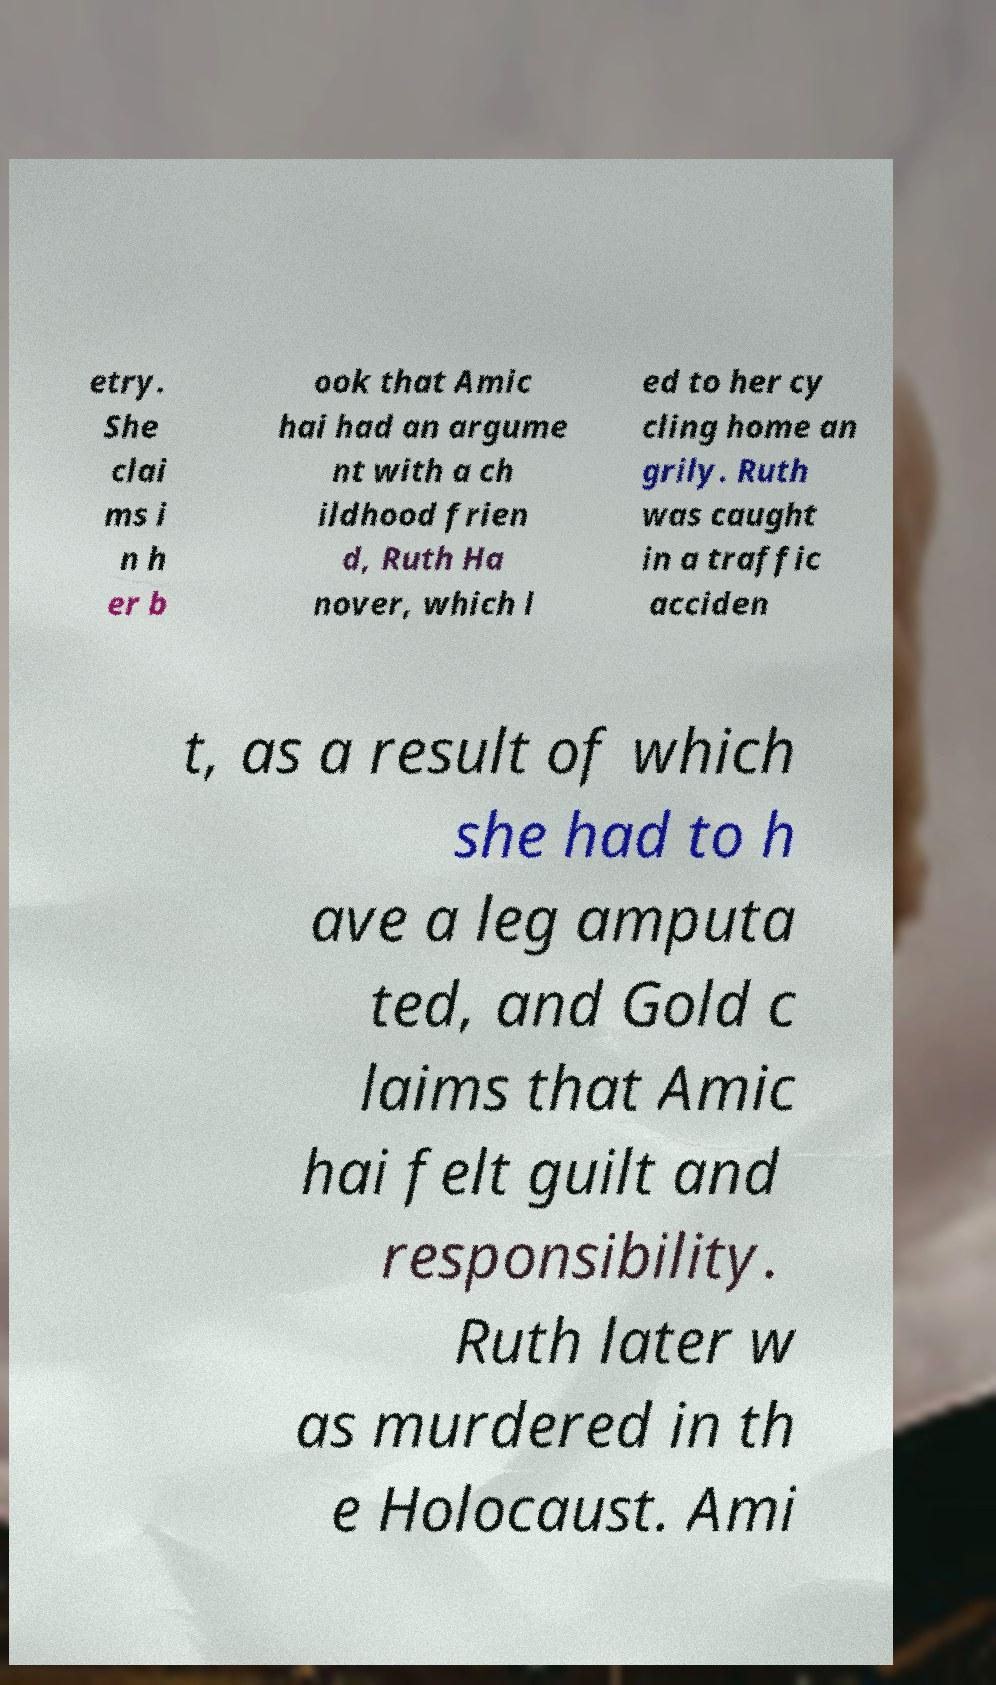Please identify and transcribe the text found in this image. etry. She clai ms i n h er b ook that Amic hai had an argume nt with a ch ildhood frien d, Ruth Ha nover, which l ed to her cy cling home an grily. Ruth was caught in a traffic acciden t, as a result of which she had to h ave a leg amputa ted, and Gold c laims that Amic hai felt guilt and responsibility. Ruth later w as murdered in th e Holocaust. Ami 